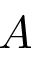Convert formula to latex. <formula><loc_0><loc_0><loc_500><loc_500>A</formula> 